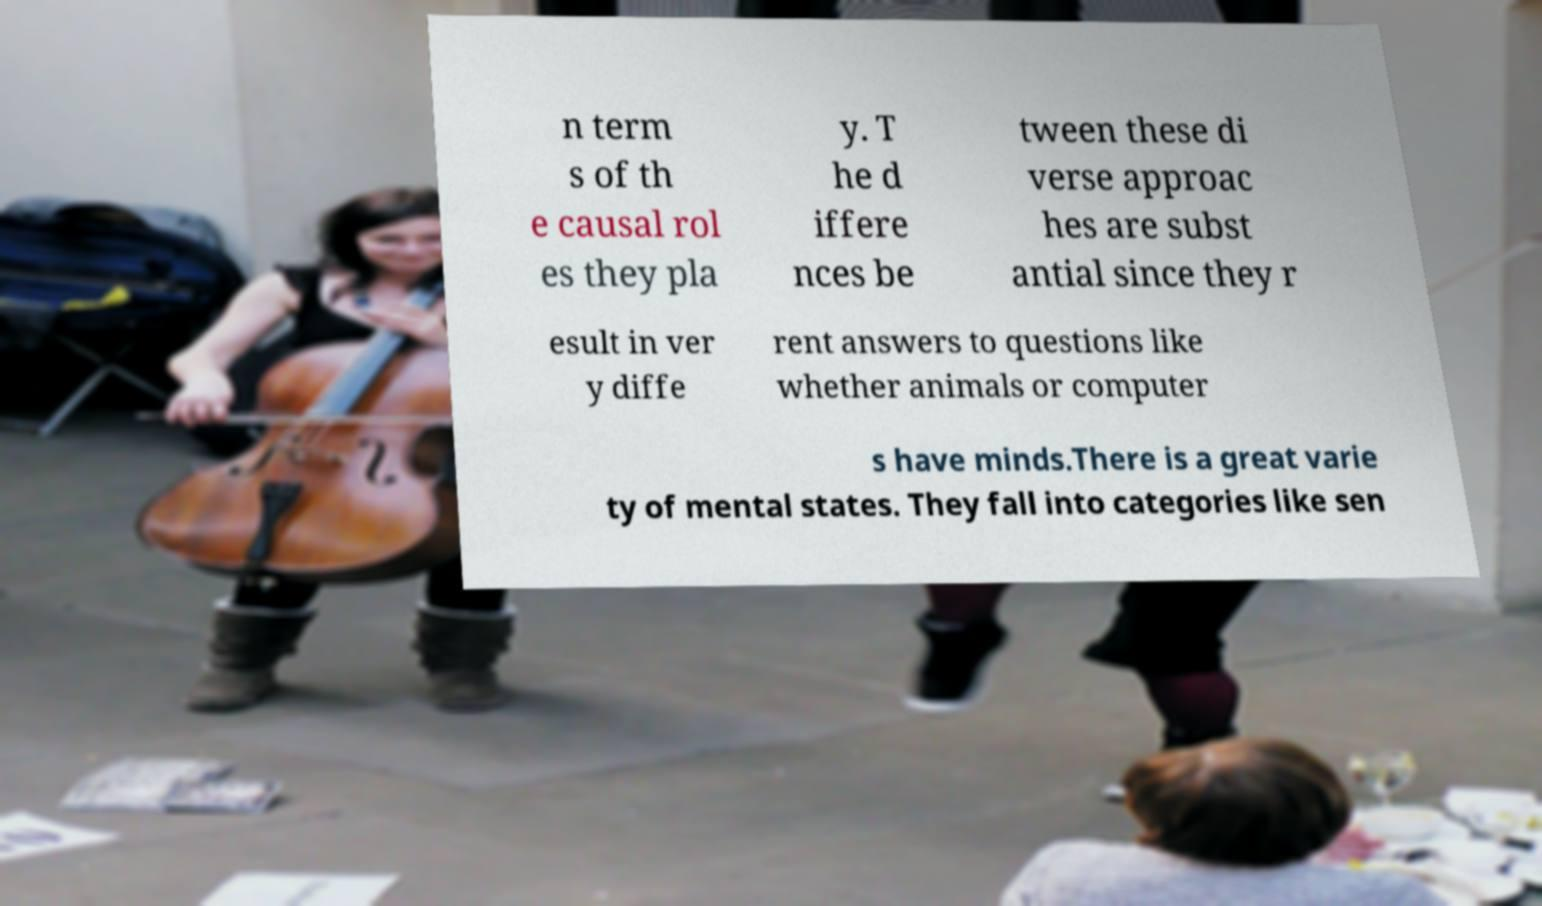There's text embedded in this image that I need extracted. Can you transcribe it verbatim? n term s of th e causal rol es they pla y. T he d iffere nces be tween these di verse approac hes are subst antial since they r esult in ver y diffe rent answers to questions like whether animals or computer s have minds.There is a great varie ty of mental states. They fall into categories like sen 